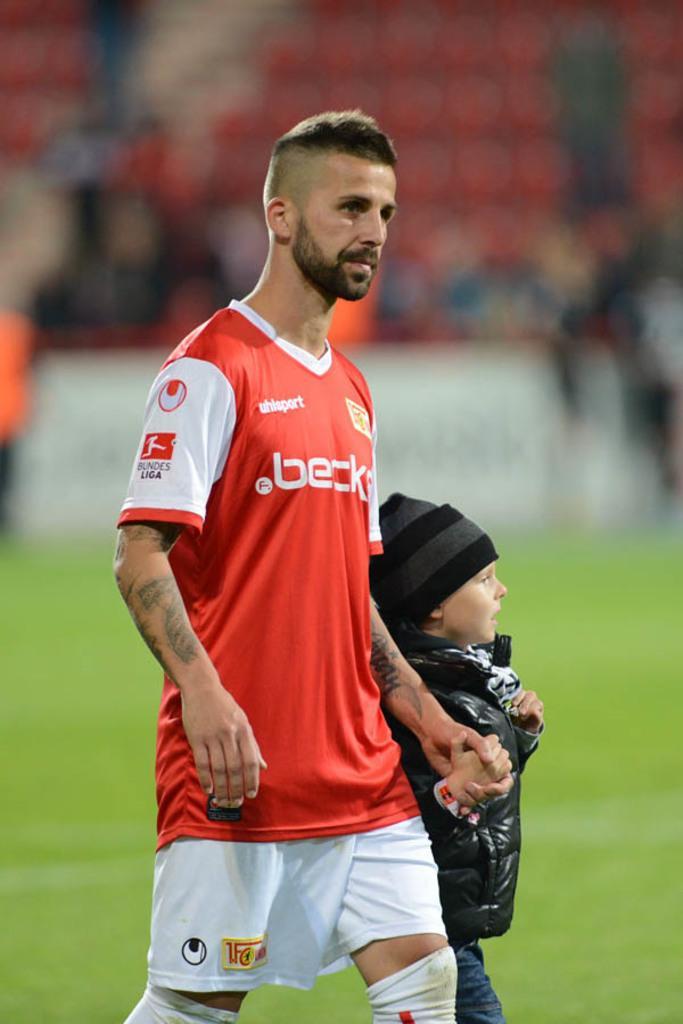In one or two sentences, can you explain what this image depicts? There is a man and a child in the foreground area of the image and the background is blurry. 